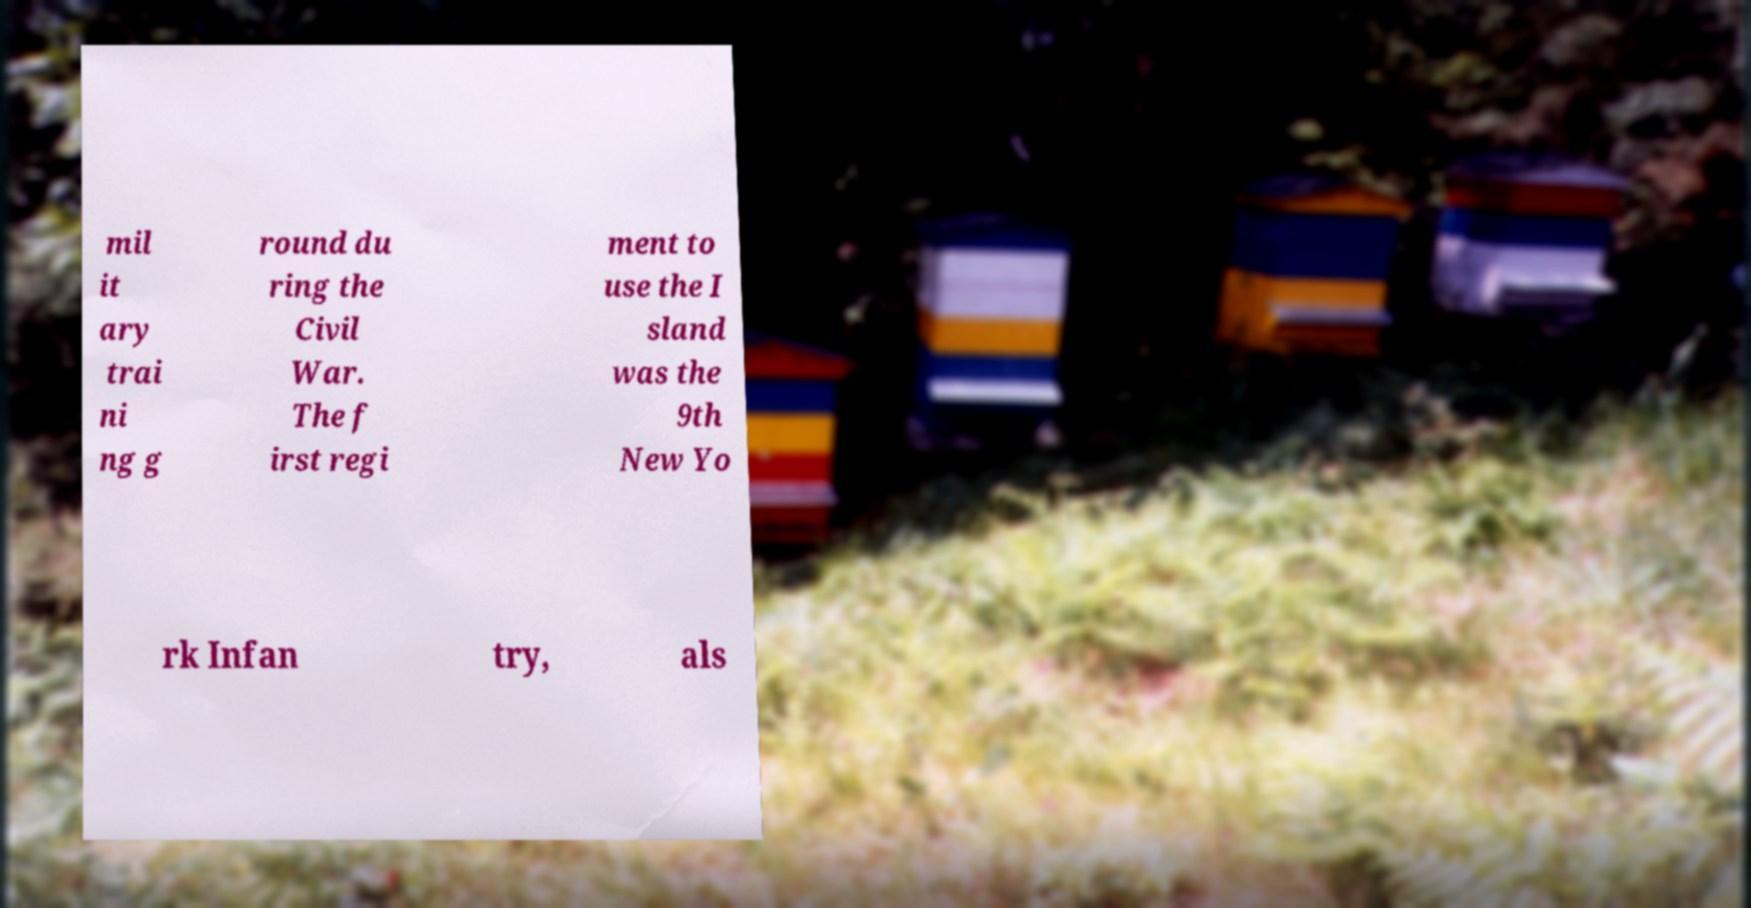What might be the significance of the content of this text in a historical context? The text refers to a military training ground during the Civil War, indicating the location's historical importance. The mention of the 9th New York Infantry reveals its role in the war, potentially offering insights into the military organization and operations of that era. How would you go about researching more information based on this text? To expand on the information provided, I would recommend investigating historical military records, visiting local history museums, or exploring online archives that focus on Civil War history. Libraries and academic resources could also provide detailed accounts of the 9th New York Infantry and its activities on the island mentioned. 